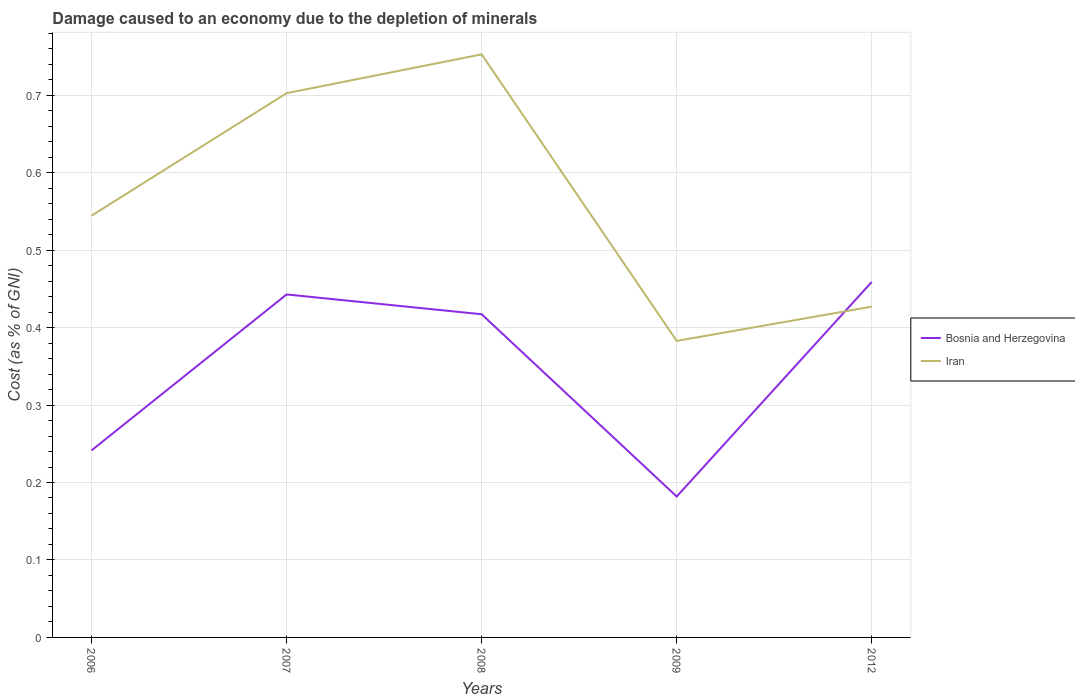How many different coloured lines are there?
Give a very brief answer. 2. Does the line corresponding to Bosnia and Herzegovina intersect with the line corresponding to Iran?
Provide a succinct answer. Yes. Across all years, what is the maximum cost of damage caused due to the depletion of minerals in Bosnia and Herzegovina?
Offer a very short reply. 0.18. What is the total cost of damage caused due to the depletion of minerals in Bosnia and Herzegovina in the graph?
Provide a short and direct response. 0.24. What is the difference between the highest and the second highest cost of damage caused due to the depletion of minerals in Iran?
Offer a very short reply. 0.37. What is the difference between the highest and the lowest cost of damage caused due to the depletion of minerals in Bosnia and Herzegovina?
Keep it short and to the point. 3. Is the cost of damage caused due to the depletion of minerals in Bosnia and Herzegovina strictly greater than the cost of damage caused due to the depletion of minerals in Iran over the years?
Make the answer very short. No. What is the difference between two consecutive major ticks on the Y-axis?
Provide a succinct answer. 0.1. Are the values on the major ticks of Y-axis written in scientific E-notation?
Your answer should be compact. No. Does the graph contain any zero values?
Ensure brevity in your answer.  No. Does the graph contain grids?
Provide a short and direct response. Yes. How many legend labels are there?
Offer a terse response. 2. How are the legend labels stacked?
Provide a succinct answer. Vertical. What is the title of the graph?
Your answer should be compact. Damage caused to an economy due to the depletion of minerals. What is the label or title of the Y-axis?
Ensure brevity in your answer.  Cost (as % of GNI). What is the Cost (as % of GNI) in Bosnia and Herzegovina in 2006?
Give a very brief answer. 0.24. What is the Cost (as % of GNI) of Iran in 2006?
Give a very brief answer. 0.54. What is the Cost (as % of GNI) in Bosnia and Herzegovina in 2007?
Offer a very short reply. 0.44. What is the Cost (as % of GNI) of Iran in 2007?
Give a very brief answer. 0.7. What is the Cost (as % of GNI) in Bosnia and Herzegovina in 2008?
Your answer should be compact. 0.42. What is the Cost (as % of GNI) in Iran in 2008?
Offer a terse response. 0.75. What is the Cost (as % of GNI) in Bosnia and Herzegovina in 2009?
Make the answer very short. 0.18. What is the Cost (as % of GNI) in Iran in 2009?
Your response must be concise. 0.38. What is the Cost (as % of GNI) of Bosnia and Herzegovina in 2012?
Offer a very short reply. 0.46. What is the Cost (as % of GNI) in Iran in 2012?
Make the answer very short. 0.43. Across all years, what is the maximum Cost (as % of GNI) in Bosnia and Herzegovina?
Your response must be concise. 0.46. Across all years, what is the maximum Cost (as % of GNI) in Iran?
Give a very brief answer. 0.75. Across all years, what is the minimum Cost (as % of GNI) in Bosnia and Herzegovina?
Offer a terse response. 0.18. Across all years, what is the minimum Cost (as % of GNI) of Iran?
Your answer should be compact. 0.38. What is the total Cost (as % of GNI) of Bosnia and Herzegovina in the graph?
Give a very brief answer. 1.74. What is the total Cost (as % of GNI) in Iran in the graph?
Give a very brief answer. 2.81. What is the difference between the Cost (as % of GNI) in Bosnia and Herzegovina in 2006 and that in 2007?
Your answer should be very brief. -0.2. What is the difference between the Cost (as % of GNI) of Iran in 2006 and that in 2007?
Keep it short and to the point. -0.16. What is the difference between the Cost (as % of GNI) in Bosnia and Herzegovina in 2006 and that in 2008?
Your answer should be compact. -0.18. What is the difference between the Cost (as % of GNI) in Iran in 2006 and that in 2008?
Provide a short and direct response. -0.21. What is the difference between the Cost (as % of GNI) in Bosnia and Herzegovina in 2006 and that in 2009?
Provide a succinct answer. 0.06. What is the difference between the Cost (as % of GNI) of Iran in 2006 and that in 2009?
Your answer should be compact. 0.16. What is the difference between the Cost (as % of GNI) in Bosnia and Herzegovina in 2006 and that in 2012?
Give a very brief answer. -0.22. What is the difference between the Cost (as % of GNI) of Iran in 2006 and that in 2012?
Offer a very short reply. 0.12. What is the difference between the Cost (as % of GNI) of Bosnia and Herzegovina in 2007 and that in 2008?
Offer a terse response. 0.03. What is the difference between the Cost (as % of GNI) in Iran in 2007 and that in 2008?
Keep it short and to the point. -0.05. What is the difference between the Cost (as % of GNI) of Bosnia and Herzegovina in 2007 and that in 2009?
Offer a terse response. 0.26. What is the difference between the Cost (as % of GNI) in Iran in 2007 and that in 2009?
Provide a short and direct response. 0.32. What is the difference between the Cost (as % of GNI) of Bosnia and Herzegovina in 2007 and that in 2012?
Ensure brevity in your answer.  -0.02. What is the difference between the Cost (as % of GNI) of Iran in 2007 and that in 2012?
Your answer should be compact. 0.28. What is the difference between the Cost (as % of GNI) in Bosnia and Herzegovina in 2008 and that in 2009?
Provide a succinct answer. 0.24. What is the difference between the Cost (as % of GNI) in Iran in 2008 and that in 2009?
Your answer should be very brief. 0.37. What is the difference between the Cost (as % of GNI) of Bosnia and Herzegovina in 2008 and that in 2012?
Your answer should be compact. -0.04. What is the difference between the Cost (as % of GNI) of Iran in 2008 and that in 2012?
Offer a terse response. 0.33. What is the difference between the Cost (as % of GNI) in Bosnia and Herzegovina in 2009 and that in 2012?
Offer a very short reply. -0.28. What is the difference between the Cost (as % of GNI) of Iran in 2009 and that in 2012?
Provide a succinct answer. -0.04. What is the difference between the Cost (as % of GNI) in Bosnia and Herzegovina in 2006 and the Cost (as % of GNI) in Iran in 2007?
Make the answer very short. -0.46. What is the difference between the Cost (as % of GNI) of Bosnia and Herzegovina in 2006 and the Cost (as % of GNI) of Iran in 2008?
Offer a terse response. -0.51. What is the difference between the Cost (as % of GNI) in Bosnia and Herzegovina in 2006 and the Cost (as % of GNI) in Iran in 2009?
Keep it short and to the point. -0.14. What is the difference between the Cost (as % of GNI) of Bosnia and Herzegovina in 2006 and the Cost (as % of GNI) of Iran in 2012?
Ensure brevity in your answer.  -0.19. What is the difference between the Cost (as % of GNI) of Bosnia and Herzegovina in 2007 and the Cost (as % of GNI) of Iran in 2008?
Ensure brevity in your answer.  -0.31. What is the difference between the Cost (as % of GNI) of Bosnia and Herzegovina in 2007 and the Cost (as % of GNI) of Iran in 2012?
Your response must be concise. 0.02. What is the difference between the Cost (as % of GNI) in Bosnia and Herzegovina in 2008 and the Cost (as % of GNI) in Iran in 2009?
Ensure brevity in your answer.  0.03. What is the difference between the Cost (as % of GNI) in Bosnia and Herzegovina in 2008 and the Cost (as % of GNI) in Iran in 2012?
Offer a terse response. -0.01. What is the difference between the Cost (as % of GNI) of Bosnia and Herzegovina in 2009 and the Cost (as % of GNI) of Iran in 2012?
Your answer should be compact. -0.25. What is the average Cost (as % of GNI) in Bosnia and Herzegovina per year?
Your response must be concise. 0.35. What is the average Cost (as % of GNI) in Iran per year?
Provide a succinct answer. 0.56. In the year 2006, what is the difference between the Cost (as % of GNI) in Bosnia and Herzegovina and Cost (as % of GNI) in Iran?
Offer a terse response. -0.3. In the year 2007, what is the difference between the Cost (as % of GNI) in Bosnia and Herzegovina and Cost (as % of GNI) in Iran?
Make the answer very short. -0.26. In the year 2008, what is the difference between the Cost (as % of GNI) of Bosnia and Herzegovina and Cost (as % of GNI) of Iran?
Your answer should be very brief. -0.34. In the year 2009, what is the difference between the Cost (as % of GNI) in Bosnia and Herzegovina and Cost (as % of GNI) in Iran?
Your answer should be compact. -0.2. In the year 2012, what is the difference between the Cost (as % of GNI) of Bosnia and Herzegovina and Cost (as % of GNI) of Iran?
Keep it short and to the point. 0.03. What is the ratio of the Cost (as % of GNI) of Bosnia and Herzegovina in 2006 to that in 2007?
Offer a terse response. 0.55. What is the ratio of the Cost (as % of GNI) of Iran in 2006 to that in 2007?
Keep it short and to the point. 0.77. What is the ratio of the Cost (as % of GNI) in Bosnia and Herzegovina in 2006 to that in 2008?
Your response must be concise. 0.58. What is the ratio of the Cost (as % of GNI) of Iran in 2006 to that in 2008?
Provide a succinct answer. 0.72. What is the ratio of the Cost (as % of GNI) of Bosnia and Herzegovina in 2006 to that in 2009?
Keep it short and to the point. 1.33. What is the ratio of the Cost (as % of GNI) in Iran in 2006 to that in 2009?
Offer a very short reply. 1.42. What is the ratio of the Cost (as % of GNI) of Bosnia and Herzegovina in 2006 to that in 2012?
Provide a short and direct response. 0.53. What is the ratio of the Cost (as % of GNI) in Iran in 2006 to that in 2012?
Offer a very short reply. 1.27. What is the ratio of the Cost (as % of GNI) of Bosnia and Herzegovina in 2007 to that in 2008?
Provide a short and direct response. 1.06. What is the ratio of the Cost (as % of GNI) in Iran in 2007 to that in 2008?
Your answer should be very brief. 0.93. What is the ratio of the Cost (as % of GNI) of Bosnia and Herzegovina in 2007 to that in 2009?
Provide a short and direct response. 2.43. What is the ratio of the Cost (as % of GNI) of Iran in 2007 to that in 2009?
Offer a very short reply. 1.84. What is the ratio of the Cost (as % of GNI) in Bosnia and Herzegovina in 2007 to that in 2012?
Provide a short and direct response. 0.96. What is the ratio of the Cost (as % of GNI) of Iran in 2007 to that in 2012?
Ensure brevity in your answer.  1.65. What is the ratio of the Cost (as % of GNI) of Bosnia and Herzegovina in 2008 to that in 2009?
Your response must be concise. 2.29. What is the ratio of the Cost (as % of GNI) in Iran in 2008 to that in 2009?
Your answer should be very brief. 1.97. What is the ratio of the Cost (as % of GNI) of Bosnia and Herzegovina in 2008 to that in 2012?
Provide a succinct answer. 0.91. What is the ratio of the Cost (as % of GNI) of Iran in 2008 to that in 2012?
Offer a very short reply. 1.76. What is the ratio of the Cost (as % of GNI) of Bosnia and Herzegovina in 2009 to that in 2012?
Offer a terse response. 0.4. What is the ratio of the Cost (as % of GNI) in Iran in 2009 to that in 2012?
Keep it short and to the point. 0.9. What is the difference between the highest and the second highest Cost (as % of GNI) in Bosnia and Herzegovina?
Offer a terse response. 0.02. What is the difference between the highest and the second highest Cost (as % of GNI) in Iran?
Offer a terse response. 0.05. What is the difference between the highest and the lowest Cost (as % of GNI) in Bosnia and Herzegovina?
Offer a terse response. 0.28. What is the difference between the highest and the lowest Cost (as % of GNI) in Iran?
Give a very brief answer. 0.37. 